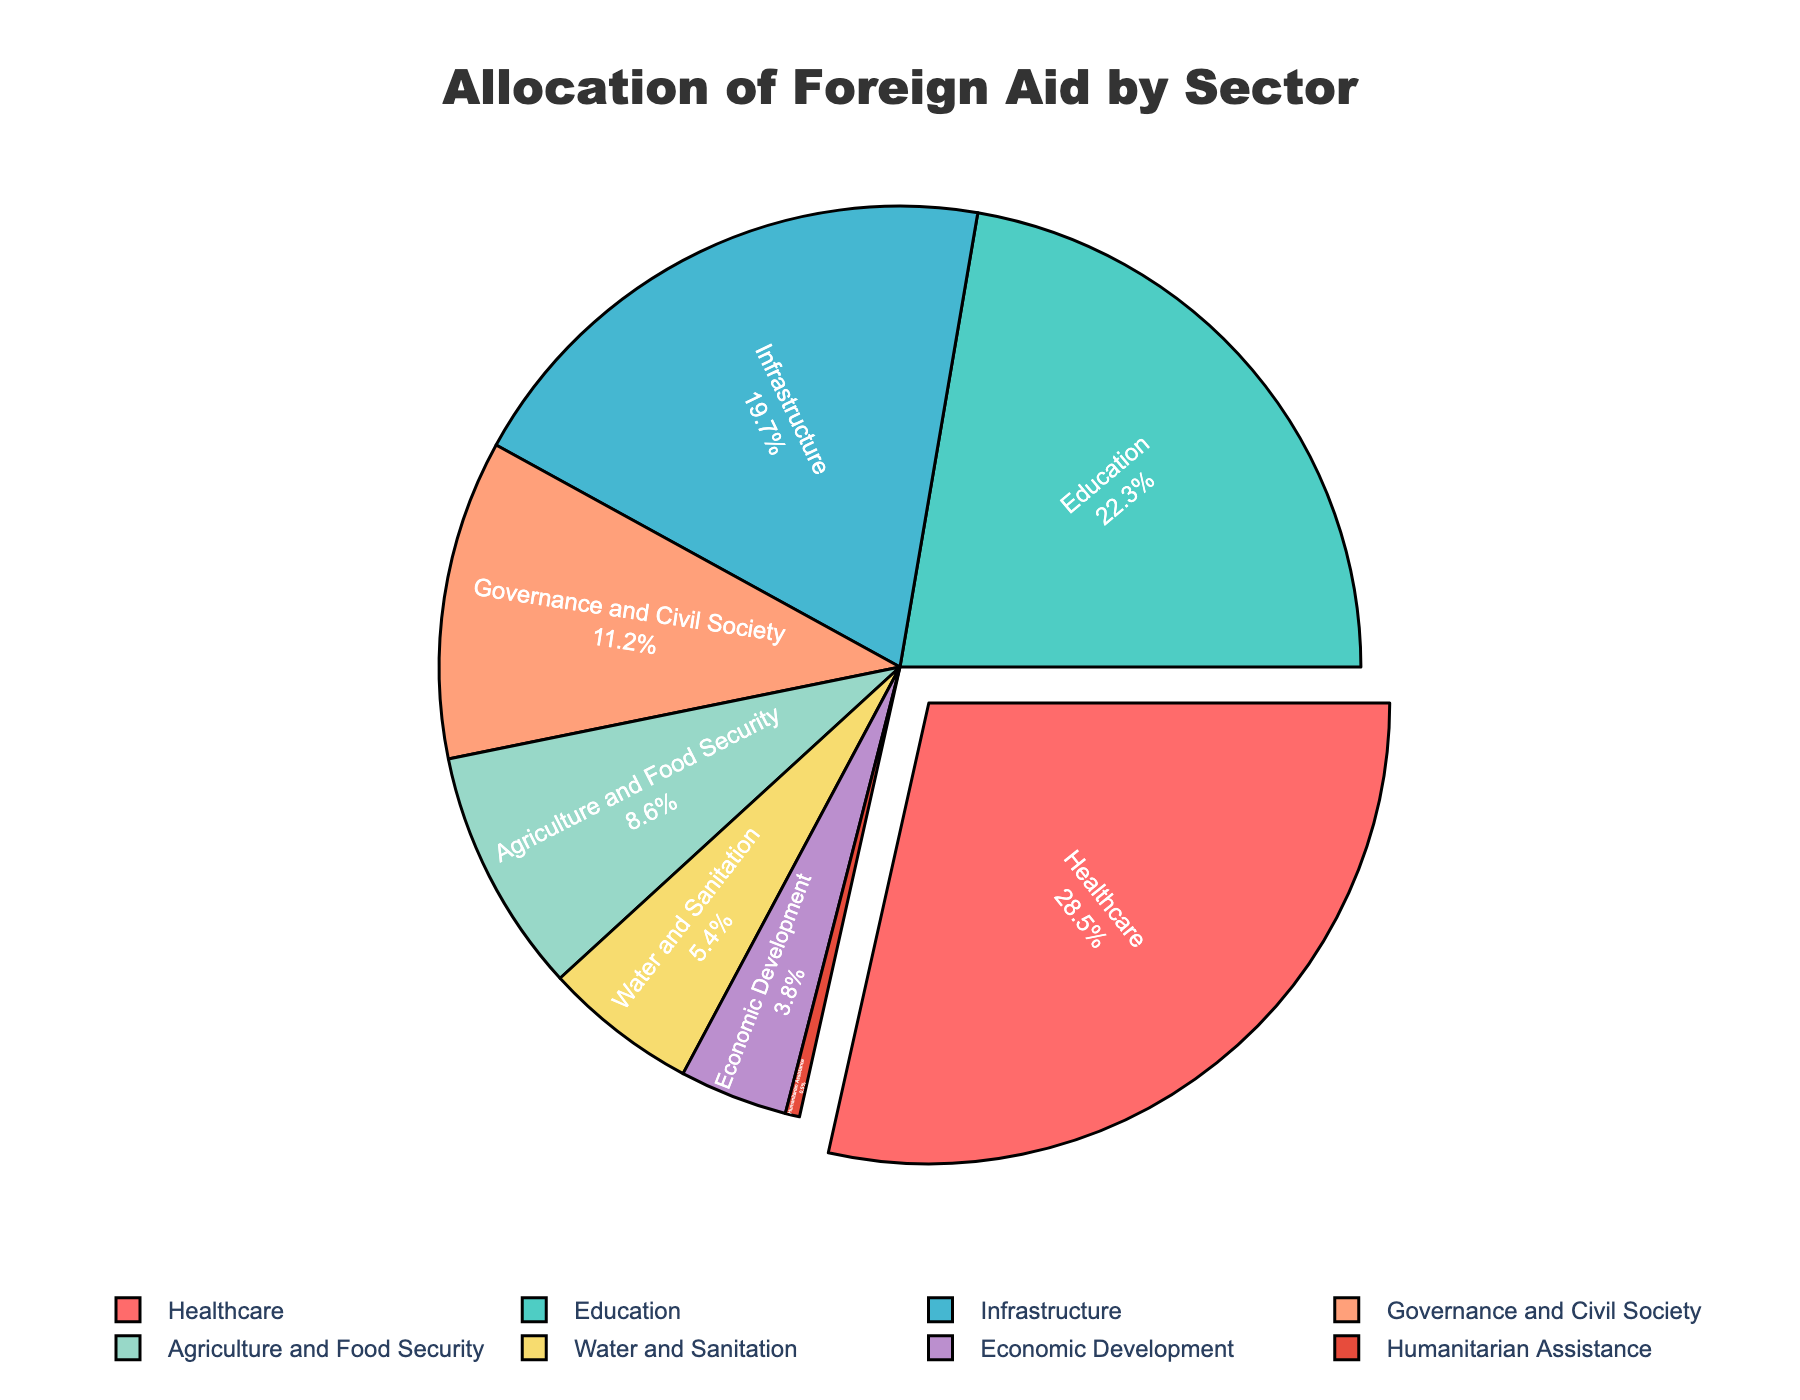What is the largest sector of foreign aid allocation represented on the pie chart? The largest sector is represented by the largest segment on the pie chart, which is Healthcare.
Answer: Healthcare Which sector has the smallest allocation of foreign aid, and what is its percentage? The smallest segment on the pie chart corresponds to Humanitarian Assistance with 0.5%.
Answer: Humanitarian Assistance, 0.5% How much more percentage of foreign aid is allocated to Healthcare compared to Water and Sanitation? Healthcare has 28.5%, and Water and Sanitation has 5.4%. The difference is 28.5% - 5.4% = 23.1%.
Answer: 23.1% Which sector receives more foreign aid: Education or Economic Development, and by how much? Education receives 22.3%, whereas Economic Development receives 3.8%. The difference is 22.3% - 3.8% = 18.5%.
Answer: Education, 18.5% What is the total percentage of foreign aid allocated to Healthcare, Education, and Infrastructure combined? Summing the percentages: Healthcare (28.5%) + Education (22.3%) + Infrastructure (19.7%) = 28.5% + 22.3% + 19.7% = 70.5%
Answer: 70.5% If the allocation to Agriculture and Food Security were increased by 2% and this amount was taken from Infrastructure, what would be the new percentages for these two sectors? Original percentages are Agriculture and Food Security (8.6%) and Infrastructure (19.7%). New percentages: Agriculture and Food Security (8.6% + 2%) = 10.6%, Infrastructure (19.7% - 2%) = 17.7%.
Answer: Agriculture and Food Security: 10.6%, Infrastructure: 17.7% Which sectors are represented using shades of green, and what are their respective percentages? The sectors colored in shades of green are Water and Sanitation (5.4%) and Education (22.3%).
Answer: Water and Sanitation: 5.4%, Education: 22.3% How many sectors have an allocation percentage greater than 10%? The sectors with an allocation percentage greater than 10% are Healthcare (28.5%), Education (22.3%), and Infrastructure (19.7%), Governance and Civil Society (11.2%)—totaling 4 sectors.
Answer: 4 What fraction of the total foreign aid is allocated to Economic Development and Humanitarian Assistance combined? The percentages are Economic Development (3.8%) and Humanitarian Assistance (0.5%). So the combined percentage is 3.8% + 0.5% = 4.3%. The fraction is 4.3/100 = 43/1000 or simplifiable to 43/1000.
Answer: 43/1000 